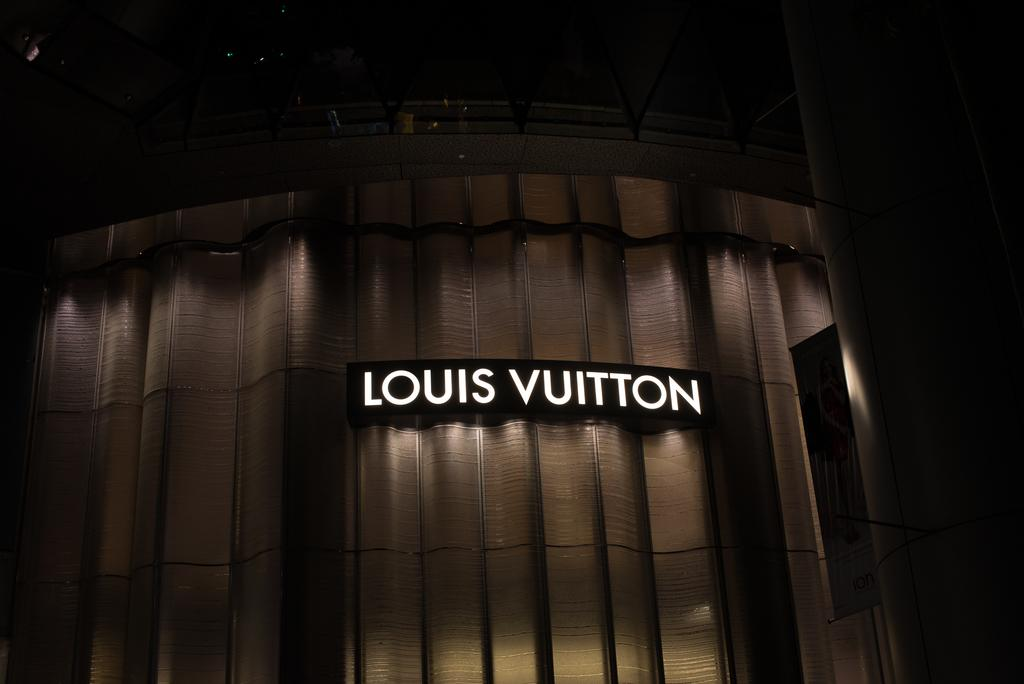What is the main subject of the picture? The main subject of the picture is a building. What can be seen written on the building? The building has "Louis Vuitton" written on it. How many eggs are visible on the building in the image? There are no eggs visible on the building in the image. What type of button can be seen on the building in the image? There are no buttons visible on the building in the image. 